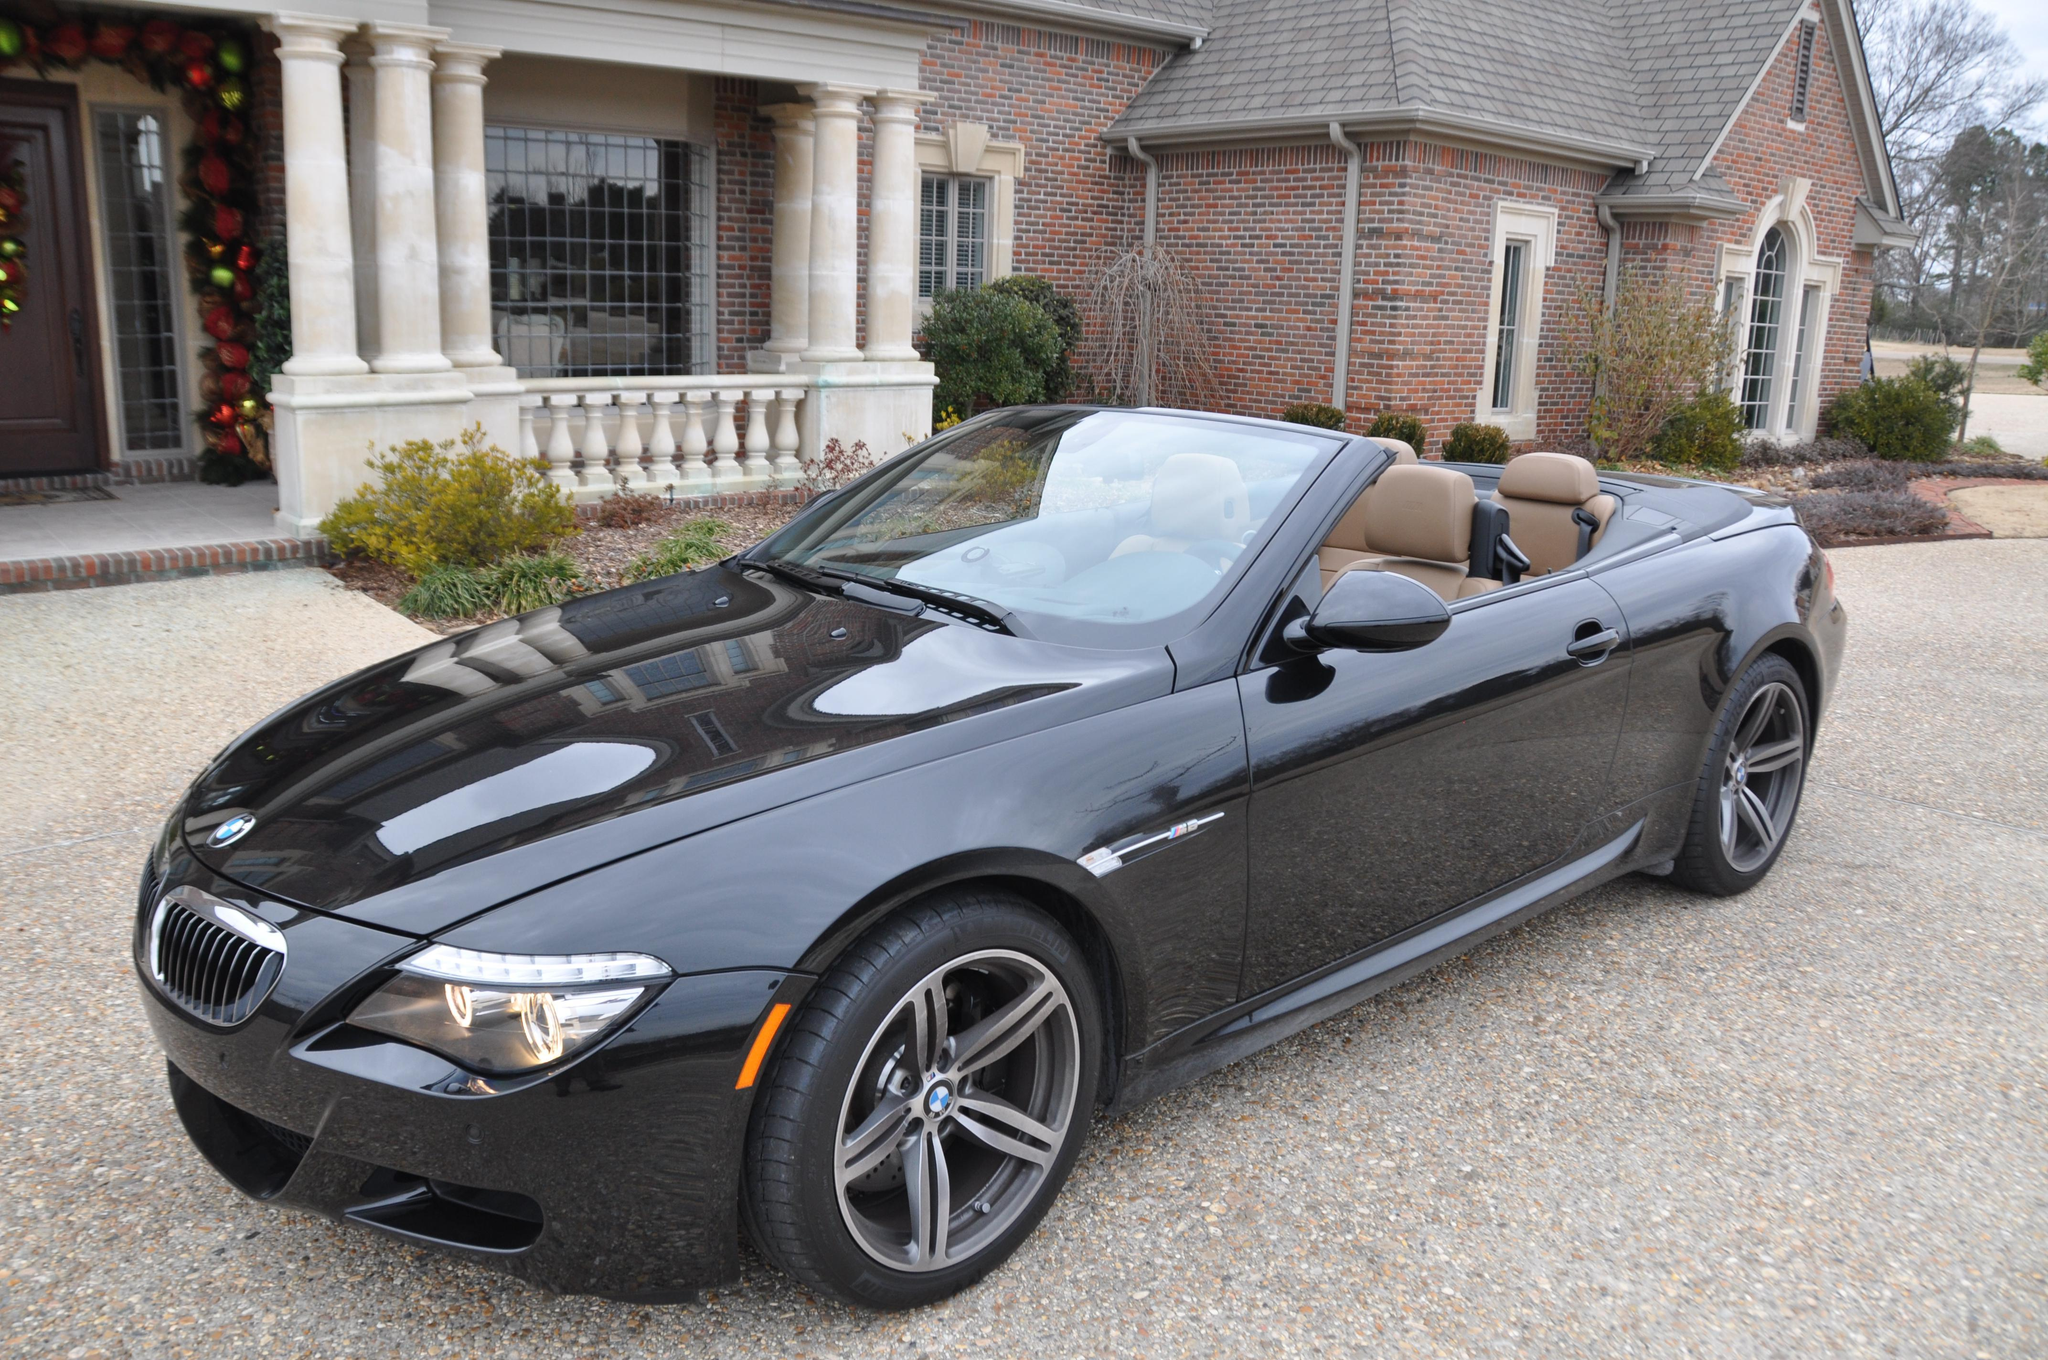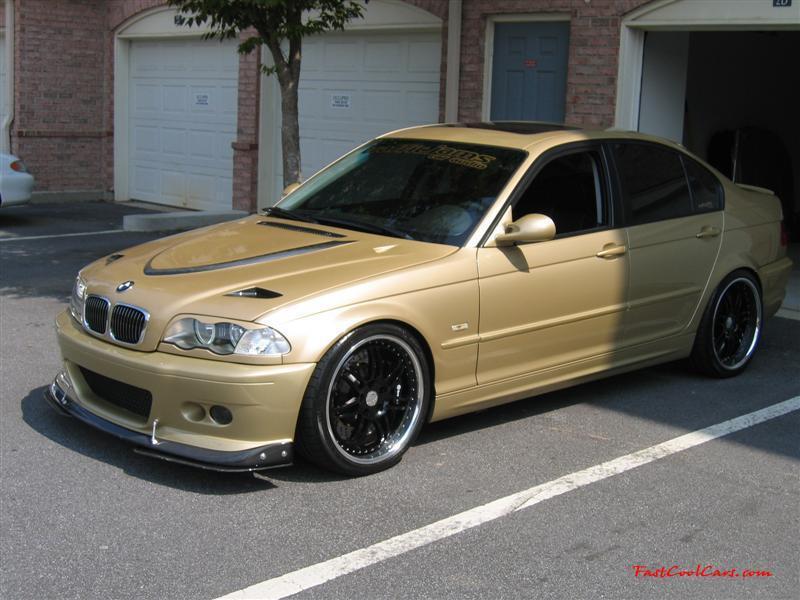The first image is the image on the left, the second image is the image on the right. Examine the images to the left and right. Is the description "One car has a hard top and the other car is a topless convertible, and the cars in the left and right images appear to face each other." accurate? Answer yes or no. No. The first image is the image on the left, the second image is the image on the right. Considering the images on both sides, is "One of the images features a white convertible car." valid? Answer yes or no. No. 